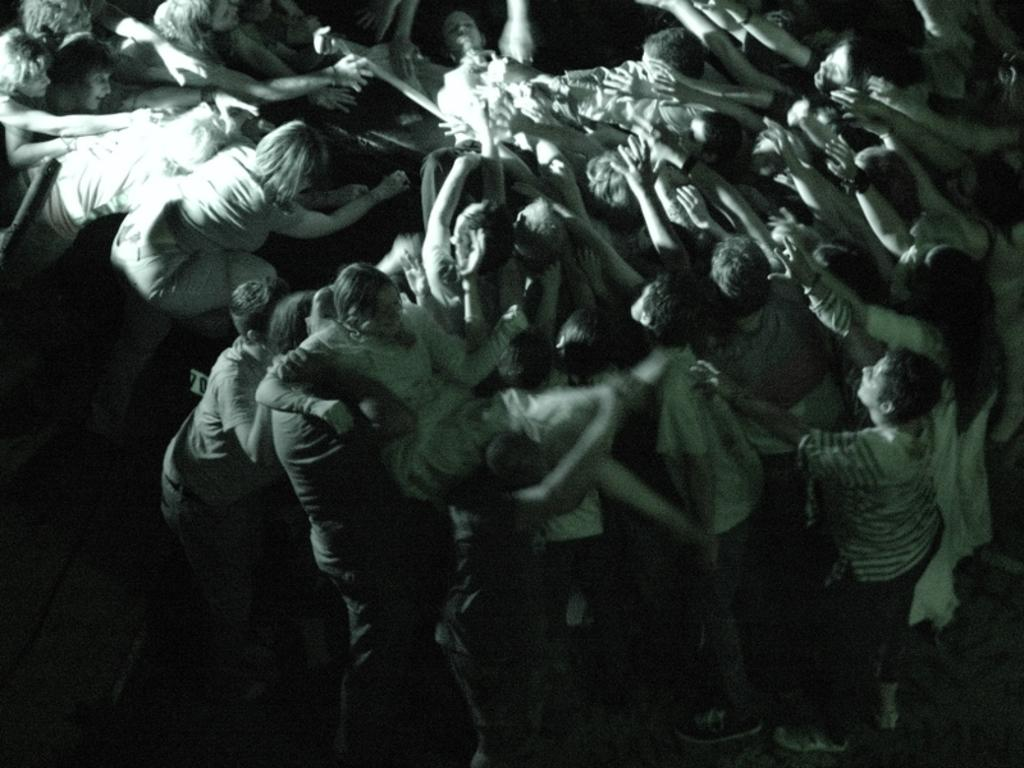How many people are in the group shown in the image? There is a group of people in the image, but the exact number is not specified. What are some people in the group doing? Some people in the group are raising their hands. What is happening to the woman in the image? There are people carrying a woman in the image. What can be seen at the top of the image? There is an object visible at the top of the image. What type of beds can be seen in the image? There are no beds present in the image. What emotion can be seen on the faces of the people in the image? The provided facts do not mention any emotions or facial expressions of the people in the image. 